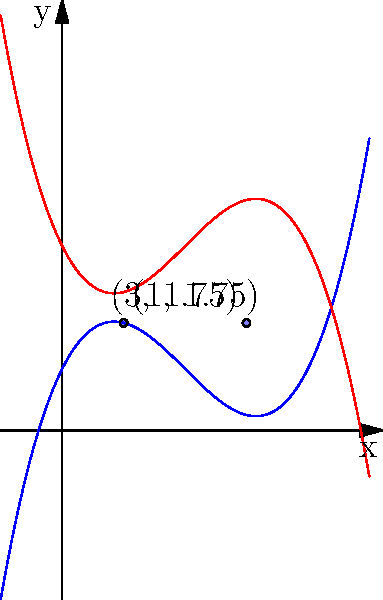In a murder mystery novel, two witnesses from different generations provide testimonies represented by polynomial functions. Witness A's testimony is represented by $f(x) = 0.25x^3 - 1.5x^2 + 2x + 1$, while Witness B's testimony is represented by $g(x) = -0.25x^3 + 1.5x^2 - 2x + 3$. The intersections of these functions symbolize overlapping information in their testimonies. What is the sum of the x-coordinates of the intersection points? To find the intersection points, we need to solve the equation $f(x) = g(x)$:

1) $0.25x^3 - 1.5x^2 + 2x + 1 = -0.25x^3 + 1.5x^2 - 2x + 3$

2) Simplify by combining like terms:
   $0.5x^3 - 3x^2 + 4x - 2 = 0$

3) Divide all terms by 0.5:
   $x^3 - 6x^2 + 8x - 4 = 0$

4) This is a cubic equation. By observation or using a graphing calculator, we can see that $x = 1$ and $x = 3$ are solutions.

5) Using the factor theorem, we can factor out $(x-1)$ and $(x-3)$:
   $(x-1)(x-3)(x-2) = 0$

6) Therefore, the intersection points are at $x = 1$, $x = 2$, and $x = 3$.

7) The sum of the x-coordinates is $1 + 2 + 3 = 6$.
Answer: 6 